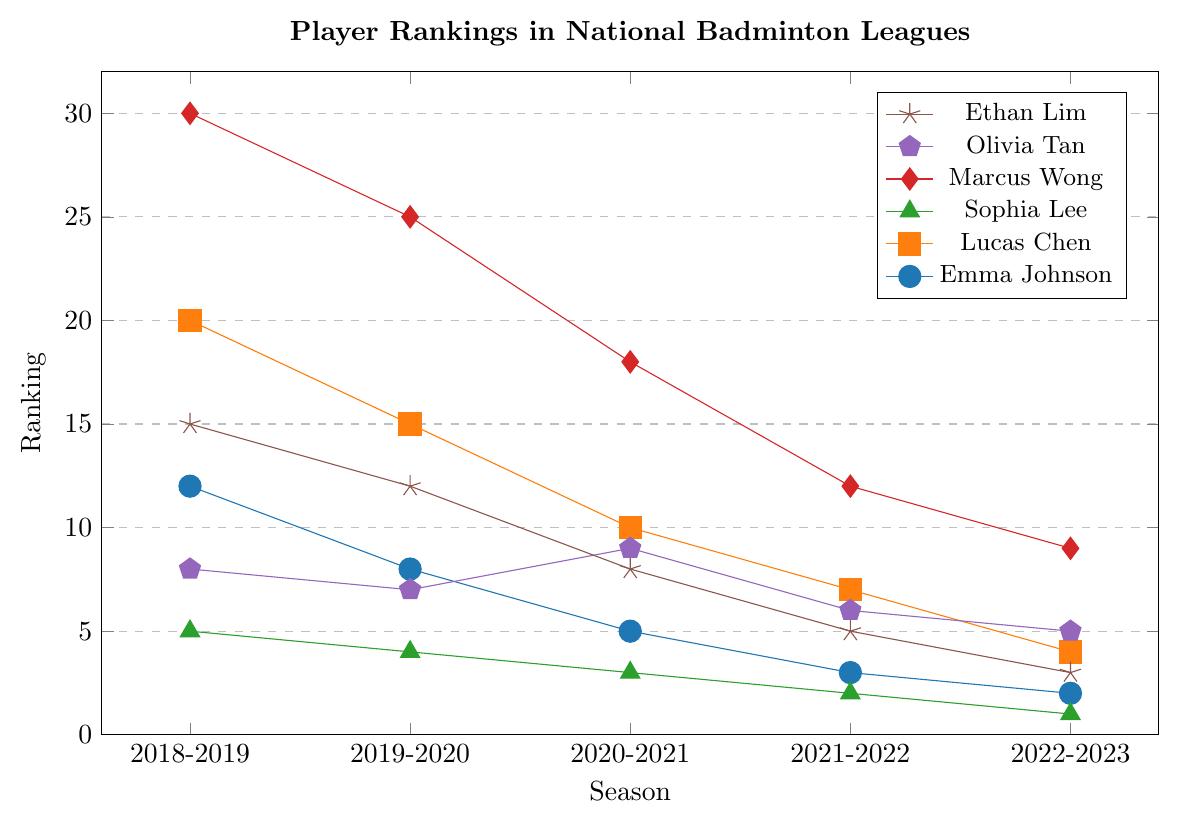What is the ranking of Emma Johnson in the 2021-2022 season? Refer to the figure where Emma Johnson's ranking points are marked with dots. Observe the dot aligned with the 2021-2022 season.
Answer: 3 Which player has shown the most consistent improvement in ranking over the seasons? Look for the player whose ranking consistently improves (lower numerical value) each season. Sophia Lee's line shows consistently decreasing values from 5 to 1 without any fluctuation.
Answer: Sophia Lee Compare the rankings of Lucas Chen and Ethan Lim in the 2020-2021 season. Who ranked higher? Check the dots representing Lucas Chen and Ethan Lim in the 2020-2021 season. Lucas Chen has a ranking of 10, and Ethan Lim has a ranking of 8. Higher rankings have lower numerical values.
Answer: Ethan Lim What is the difference in the ranking between Marcus Wong and Olivia Tan in the 2022-2023 season? Observe the dots for Marcus Wong and Olivia Tan for the 2022-2023 season. Marcus Wong's ranking is 9, and Olivia Tan's ranking is 5. Calculate the difference, 9 - 5.
Answer: 4 What is the average ranking of Emma Johnson over the five seasons? Sum Emma Johnson's rankings for five seasons (12 + 8 + 5 + 3 + 2) and divide by the number of seasons (5). The calculation is (12 + 8 + 5 + 3 + 2) / 5.
Answer: 6 How many players maintained the same ranking in two consecutive seasons? Examine the trajectories of each player and check for flat segments where their ranking stayed the same. No player has the same ranking in consecutive seasons.
Answer: 0 Which player had the largest drop in ranking between two consecutive seasons? Analyze each player's ranking changes between consecutive seasons. Olivia Tan's ranking dropped from 7 to 9 between the 2019-2020 and 2020-2021 seasons, the largest observed single-season drop.
Answer: Olivia Tan In the 2018-2019 season, which player's ranking was between 10 and 20? Check the rankings for all players in the 2018-2019 season and identify those within the specified range of 10 to 20. Emma Johnson (12), Lucas Chen (20), and Ethan Lim (15) fall within this range.
Answer: Emma Johnson, Lucas Chen, Ethan Lim What is the median ranking for Ethan Lim over the seasons? List Ethan Lim's rankings across the seasons (15, 12, 8, 5, 3). To find the median ranking, identify the middle value in the ordered list. The median is 8 (the third value).
Answer: 8 Compare the trend of Marcus Wong and Sophia Lee's rankings. Who improved more significantly by the end of the 2022-2023 season? Track the changes in rankings from 2018-2019 to 2022-2023 for both players. Marcus Wong improves from 30 to 9 (a change of 21), whereas Sophia Lee improves from 5 to 1 (a change of 4).
Answer: Marcus Wong 